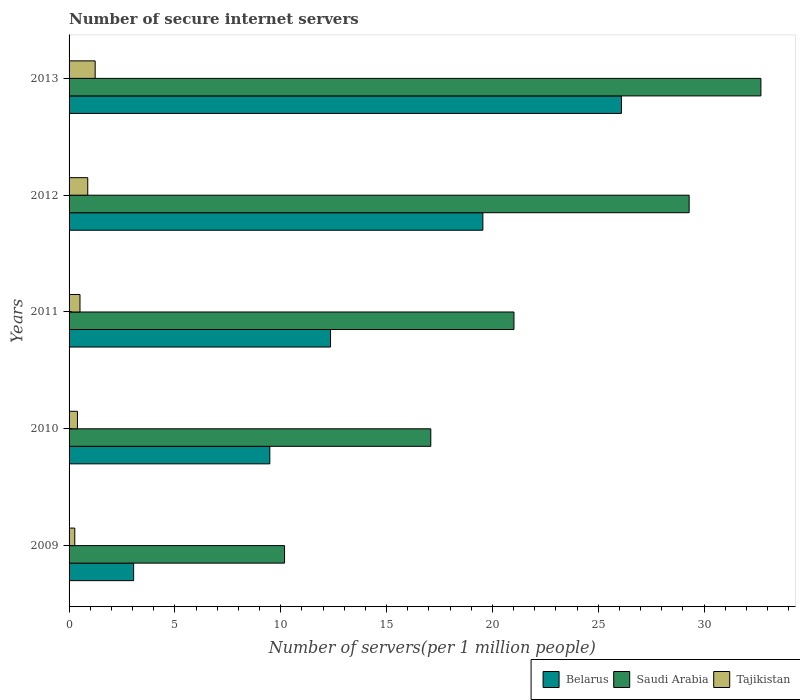How many groups of bars are there?
Ensure brevity in your answer.  5. How many bars are there on the 1st tick from the bottom?
Ensure brevity in your answer.  3. What is the number of secure internet servers in Belarus in 2012?
Offer a very short reply. 19.55. Across all years, what is the maximum number of secure internet servers in Belarus?
Provide a short and direct response. 26.09. Across all years, what is the minimum number of secure internet servers in Tajikistan?
Give a very brief answer. 0.27. In which year was the number of secure internet servers in Belarus maximum?
Provide a succinct answer. 2013. What is the total number of secure internet servers in Tajikistan in the graph?
Provide a short and direct response. 3.3. What is the difference between the number of secure internet servers in Belarus in 2009 and that in 2010?
Your response must be concise. -6.43. What is the difference between the number of secure internet servers in Saudi Arabia in 2009 and the number of secure internet servers in Tajikistan in 2013?
Provide a short and direct response. 8.95. What is the average number of secure internet servers in Belarus per year?
Give a very brief answer. 14.11. In the year 2012, what is the difference between the number of secure internet servers in Tajikistan and number of secure internet servers in Belarus?
Ensure brevity in your answer.  -18.67. In how many years, is the number of secure internet servers in Tajikistan greater than 21 ?
Your answer should be compact. 0. What is the ratio of the number of secure internet servers in Belarus in 2009 to that in 2010?
Keep it short and to the point. 0.32. Is the number of secure internet servers in Tajikistan in 2011 less than that in 2013?
Make the answer very short. Yes. What is the difference between the highest and the second highest number of secure internet servers in Saudi Arabia?
Ensure brevity in your answer.  3.39. What is the difference between the highest and the lowest number of secure internet servers in Saudi Arabia?
Your answer should be compact. 22.5. What does the 3rd bar from the top in 2013 represents?
Give a very brief answer. Belarus. What does the 1st bar from the bottom in 2010 represents?
Ensure brevity in your answer.  Belarus. Is it the case that in every year, the sum of the number of secure internet servers in Saudi Arabia and number of secure internet servers in Belarus is greater than the number of secure internet servers in Tajikistan?
Your answer should be compact. Yes. How many bars are there?
Your answer should be compact. 15. How many years are there in the graph?
Give a very brief answer. 5. Does the graph contain grids?
Your answer should be compact. No. How are the legend labels stacked?
Provide a succinct answer. Horizontal. What is the title of the graph?
Your response must be concise. Number of secure internet servers. Does "Seychelles" appear as one of the legend labels in the graph?
Give a very brief answer. No. What is the label or title of the X-axis?
Offer a very short reply. Number of servers(per 1 million people). What is the Number of servers(per 1 million people) in Belarus in 2009?
Provide a succinct answer. 3.05. What is the Number of servers(per 1 million people) in Saudi Arabia in 2009?
Provide a short and direct response. 10.18. What is the Number of servers(per 1 million people) of Tajikistan in 2009?
Provide a short and direct response. 0.27. What is the Number of servers(per 1 million people) in Belarus in 2010?
Give a very brief answer. 9.48. What is the Number of servers(per 1 million people) in Saudi Arabia in 2010?
Offer a very short reply. 17.09. What is the Number of servers(per 1 million people) of Tajikistan in 2010?
Your response must be concise. 0.4. What is the Number of servers(per 1 million people) of Belarus in 2011?
Offer a very short reply. 12.35. What is the Number of servers(per 1 million people) of Saudi Arabia in 2011?
Make the answer very short. 21.02. What is the Number of servers(per 1 million people) in Tajikistan in 2011?
Offer a very short reply. 0.52. What is the Number of servers(per 1 million people) of Belarus in 2012?
Offer a very short reply. 19.55. What is the Number of servers(per 1 million people) in Saudi Arabia in 2012?
Your answer should be very brief. 29.29. What is the Number of servers(per 1 million people) in Tajikistan in 2012?
Your answer should be compact. 0.88. What is the Number of servers(per 1 million people) in Belarus in 2013?
Your response must be concise. 26.09. What is the Number of servers(per 1 million people) of Saudi Arabia in 2013?
Ensure brevity in your answer.  32.68. What is the Number of servers(per 1 million people) in Tajikistan in 2013?
Your answer should be very brief. 1.23. Across all years, what is the maximum Number of servers(per 1 million people) in Belarus?
Your answer should be compact. 26.09. Across all years, what is the maximum Number of servers(per 1 million people) in Saudi Arabia?
Provide a short and direct response. 32.68. Across all years, what is the maximum Number of servers(per 1 million people) in Tajikistan?
Ensure brevity in your answer.  1.23. Across all years, what is the minimum Number of servers(per 1 million people) of Belarus?
Ensure brevity in your answer.  3.05. Across all years, what is the minimum Number of servers(per 1 million people) of Saudi Arabia?
Provide a short and direct response. 10.18. Across all years, what is the minimum Number of servers(per 1 million people) of Tajikistan?
Offer a very short reply. 0.27. What is the total Number of servers(per 1 million people) in Belarus in the graph?
Your answer should be very brief. 70.53. What is the total Number of servers(per 1 million people) in Saudi Arabia in the graph?
Keep it short and to the point. 110.25. What is the total Number of servers(per 1 million people) of Tajikistan in the graph?
Your response must be concise. 3.3. What is the difference between the Number of servers(per 1 million people) of Belarus in 2009 and that in 2010?
Offer a very short reply. -6.43. What is the difference between the Number of servers(per 1 million people) of Saudi Arabia in 2009 and that in 2010?
Your answer should be compact. -6.91. What is the difference between the Number of servers(per 1 million people) of Tajikistan in 2009 and that in 2010?
Make the answer very short. -0.13. What is the difference between the Number of servers(per 1 million people) of Belarus in 2009 and that in 2011?
Your answer should be compact. -9.3. What is the difference between the Number of servers(per 1 million people) in Saudi Arabia in 2009 and that in 2011?
Your response must be concise. -10.84. What is the difference between the Number of servers(per 1 million people) in Tajikistan in 2009 and that in 2011?
Give a very brief answer. -0.25. What is the difference between the Number of servers(per 1 million people) of Belarus in 2009 and that in 2012?
Your response must be concise. -16.5. What is the difference between the Number of servers(per 1 million people) of Saudi Arabia in 2009 and that in 2012?
Ensure brevity in your answer.  -19.11. What is the difference between the Number of servers(per 1 million people) in Tajikistan in 2009 and that in 2012?
Offer a terse response. -0.61. What is the difference between the Number of servers(per 1 million people) of Belarus in 2009 and that in 2013?
Make the answer very short. -23.04. What is the difference between the Number of servers(per 1 million people) in Saudi Arabia in 2009 and that in 2013?
Keep it short and to the point. -22.5. What is the difference between the Number of servers(per 1 million people) in Tajikistan in 2009 and that in 2013?
Ensure brevity in your answer.  -0.96. What is the difference between the Number of servers(per 1 million people) of Belarus in 2010 and that in 2011?
Offer a terse response. -2.87. What is the difference between the Number of servers(per 1 million people) of Saudi Arabia in 2010 and that in 2011?
Your response must be concise. -3.93. What is the difference between the Number of servers(per 1 million people) of Tajikistan in 2010 and that in 2011?
Your response must be concise. -0.12. What is the difference between the Number of servers(per 1 million people) of Belarus in 2010 and that in 2012?
Give a very brief answer. -10.06. What is the difference between the Number of servers(per 1 million people) in Saudi Arabia in 2010 and that in 2012?
Ensure brevity in your answer.  -12.2. What is the difference between the Number of servers(per 1 million people) of Tajikistan in 2010 and that in 2012?
Offer a terse response. -0.49. What is the difference between the Number of servers(per 1 million people) of Belarus in 2010 and that in 2013?
Your answer should be compact. -16.61. What is the difference between the Number of servers(per 1 million people) of Saudi Arabia in 2010 and that in 2013?
Provide a short and direct response. -15.59. What is the difference between the Number of servers(per 1 million people) of Tajikistan in 2010 and that in 2013?
Provide a succinct answer. -0.84. What is the difference between the Number of servers(per 1 million people) in Belarus in 2011 and that in 2012?
Your answer should be very brief. -7.2. What is the difference between the Number of servers(per 1 million people) in Saudi Arabia in 2011 and that in 2012?
Keep it short and to the point. -8.28. What is the difference between the Number of servers(per 1 million people) of Tajikistan in 2011 and that in 2012?
Your answer should be compact. -0.37. What is the difference between the Number of servers(per 1 million people) of Belarus in 2011 and that in 2013?
Make the answer very short. -13.74. What is the difference between the Number of servers(per 1 million people) in Saudi Arabia in 2011 and that in 2013?
Offer a terse response. -11.67. What is the difference between the Number of servers(per 1 million people) in Tajikistan in 2011 and that in 2013?
Your answer should be very brief. -0.72. What is the difference between the Number of servers(per 1 million people) of Belarus in 2012 and that in 2013?
Ensure brevity in your answer.  -6.55. What is the difference between the Number of servers(per 1 million people) of Saudi Arabia in 2012 and that in 2013?
Provide a succinct answer. -3.39. What is the difference between the Number of servers(per 1 million people) of Tajikistan in 2012 and that in 2013?
Your answer should be very brief. -0.35. What is the difference between the Number of servers(per 1 million people) of Belarus in 2009 and the Number of servers(per 1 million people) of Saudi Arabia in 2010?
Your response must be concise. -14.04. What is the difference between the Number of servers(per 1 million people) of Belarus in 2009 and the Number of servers(per 1 million people) of Tajikistan in 2010?
Your answer should be compact. 2.65. What is the difference between the Number of servers(per 1 million people) in Saudi Arabia in 2009 and the Number of servers(per 1 million people) in Tajikistan in 2010?
Your answer should be very brief. 9.78. What is the difference between the Number of servers(per 1 million people) of Belarus in 2009 and the Number of servers(per 1 million people) of Saudi Arabia in 2011?
Make the answer very short. -17.96. What is the difference between the Number of servers(per 1 million people) in Belarus in 2009 and the Number of servers(per 1 million people) in Tajikistan in 2011?
Give a very brief answer. 2.53. What is the difference between the Number of servers(per 1 million people) in Saudi Arabia in 2009 and the Number of servers(per 1 million people) in Tajikistan in 2011?
Your response must be concise. 9.66. What is the difference between the Number of servers(per 1 million people) of Belarus in 2009 and the Number of servers(per 1 million people) of Saudi Arabia in 2012?
Offer a terse response. -26.24. What is the difference between the Number of servers(per 1 million people) of Belarus in 2009 and the Number of servers(per 1 million people) of Tajikistan in 2012?
Ensure brevity in your answer.  2.17. What is the difference between the Number of servers(per 1 million people) of Saudi Arabia in 2009 and the Number of servers(per 1 million people) of Tajikistan in 2012?
Keep it short and to the point. 9.3. What is the difference between the Number of servers(per 1 million people) in Belarus in 2009 and the Number of servers(per 1 million people) in Saudi Arabia in 2013?
Give a very brief answer. -29.63. What is the difference between the Number of servers(per 1 million people) of Belarus in 2009 and the Number of servers(per 1 million people) of Tajikistan in 2013?
Give a very brief answer. 1.82. What is the difference between the Number of servers(per 1 million people) in Saudi Arabia in 2009 and the Number of servers(per 1 million people) in Tajikistan in 2013?
Offer a terse response. 8.95. What is the difference between the Number of servers(per 1 million people) of Belarus in 2010 and the Number of servers(per 1 million people) of Saudi Arabia in 2011?
Your response must be concise. -11.53. What is the difference between the Number of servers(per 1 million people) of Belarus in 2010 and the Number of servers(per 1 million people) of Tajikistan in 2011?
Offer a terse response. 8.97. What is the difference between the Number of servers(per 1 million people) in Saudi Arabia in 2010 and the Number of servers(per 1 million people) in Tajikistan in 2011?
Your answer should be compact. 16.57. What is the difference between the Number of servers(per 1 million people) of Belarus in 2010 and the Number of servers(per 1 million people) of Saudi Arabia in 2012?
Make the answer very short. -19.81. What is the difference between the Number of servers(per 1 million people) in Belarus in 2010 and the Number of servers(per 1 million people) in Tajikistan in 2012?
Make the answer very short. 8.6. What is the difference between the Number of servers(per 1 million people) of Saudi Arabia in 2010 and the Number of servers(per 1 million people) of Tajikistan in 2012?
Ensure brevity in your answer.  16.2. What is the difference between the Number of servers(per 1 million people) of Belarus in 2010 and the Number of servers(per 1 million people) of Saudi Arabia in 2013?
Ensure brevity in your answer.  -23.2. What is the difference between the Number of servers(per 1 million people) of Belarus in 2010 and the Number of servers(per 1 million people) of Tajikistan in 2013?
Ensure brevity in your answer.  8.25. What is the difference between the Number of servers(per 1 million people) in Saudi Arabia in 2010 and the Number of servers(per 1 million people) in Tajikistan in 2013?
Your response must be concise. 15.85. What is the difference between the Number of servers(per 1 million people) of Belarus in 2011 and the Number of servers(per 1 million people) of Saudi Arabia in 2012?
Keep it short and to the point. -16.94. What is the difference between the Number of servers(per 1 million people) in Belarus in 2011 and the Number of servers(per 1 million people) in Tajikistan in 2012?
Ensure brevity in your answer.  11.47. What is the difference between the Number of servers(per 1 million people) of Saudi Arabia in 2011 and the Number of servers(per 1 million people) of Tajikistan in 2012?
Keep it short and to the point. 20.13. What is the difference between the Number of servers(per 1 million people) in Belarus in 2011 and the Number of servers(per 1 million people) in Saudi Arabia in 2013?
Your answer should be compact. -20.33. What is the difference between the Number of servers(per 1 million people) in Belarus in 2011 and the Number of servers(per 1 million people) in Tajikistan in 2013?
Ensure brevity in your answer.  11.12. What is the difference between the Number of servers(per 1 million people) of Saudi Arabia in 2011 and the Number of servers(per 1 million people) of Tajikistan in 2013?
Give a very brief answer. 19.78. What is the difference between the Number of servers(per 1 million people) of Belarus in 2012 and the Number of servers(per 1 million people) of Saudi Arabia in 2013?
Make the answer very short. -13.13. What is the difference between the Number of servers(per 1 million people) of Belarus in 2012 and the Number of servers(per 1 million people) of Tajikistan in 2013?
Your response must be concise. 18.32. What is the difference between the Number of servers(per 1 million people) of Saudi Arabia in 2012 and the Number of servers(per 1 million people) of Tajikistan in 2013?
Give a very brief answer. 28.06. What is the average Number of servers(per 1 million people) in Belarus per year?
Give a very brief answer. 14.11. What is the average Number of servers(per 1 million people) of Saudi Arabia per year?
Your answer should be very brief. 22.05. What is the average Number of servers(per 1 million people) of Tajikistan per year?
Give a very brief answer. 0.66. In the year 2009, what is the difference between the Number of servers(per 1 million people) in Belarus and Number of servers(per 1 million people) in Saudi Arabia?
Your response must be concise. -7.13. In the year 2009, what is the difference between the Number of servers(per 1 million people) of Belarus and Number of servers(per 1 million people) of Tajikistan?
Provide a short and direct response. 2.78. In the year 2009, what is the difference between the Number of servers(per 1 million people) in Saudi Arabia and Number of servers(per 1 million people) in Tajikistan?
Ensure brevity in your answer.  9.91. In the year 2010, what is the difference between the Number of servers(per 1 million people) in Belarus and Number of servers(per 1 million people) in Saudi Arabia?
Give a very brief answer. -7.6. In the year 2010, what is the difference between the Number of servers(per 1 million people) in Belarus and Number of servers(per 1 million people) in Tajikistan?
Keep it short and to the point. 9.09. In the year 2010, what is the difference between the Number of servers(per 1 million people) of Saudi Arabia and Number of servers(per 1 million people) of Tajikistan?
Keep it short and to the point. 16.69. In the year 2011, what is the difference between the Number of servers(per 1 million people) in Belarus and Number of servers(per 1 million people) in Saudi Arabia?
Give a very brief answer. -8.66. In the year 2011, what is the difference between the Number of servers(per 1 million people) in Belarus and Number of servers(per 1 million people) in Tajikistan?
Offer a terse response. 11.84. In the year 2011, what is the difference between the Number of servers(per 1 million people) of Saudi Arabia and Number of servers(per 1 million people) of Tajikistan?
Make the answer very short. 20.5. In the year 2012, what is the difference between the Number of servers(per 1 million people) of Belarus and Number of servers(per 1 million people) of Saudi Arabia?
Provide a succinct answer. -9.74. In the year 2012, what is the difference between the Number of servers(per 1 million people) in Belarus and Number of servers(per 1 million people) in Tajikistan?
Your answer should be compact. 18.67. In the year 2012, what is the difference between the Number of servers(per 1 million people) in Saudi Arabia and Number of servers(per 1 million people) in Tajikistan?
Offer a terse response. 28.41. In the year 2013, what is the difference between the Number of servers(per 1 million people) in Belarus and Number of servers(per 1 million people) in Saudi Arabia?
Give a very brief answer. -6.59. In the year 2013, what is the difference between the Number of servers(per 1 million people) of Belarus and Number of servers(per 1 million people) of Tajikistan?
Keep it short and to the point. 24.86. In the year 2013, what is the difference between the Number of servers(per 1 million people) of Saudi Arabia and Number of servers(per 1 million people) of Tajikistan?
Provide a short and direct response. 31.45. What is the ratio of the Number of servers(per 1 million people) in Belarus in 2009 to that in 2010?
Your answer should be very brief. 0.32. What is the ratio of the Number of servers(per 1 million people) of Saudi Arabia in 2009 to that in 2010?
Ensure brevity in your answer.  0.6. What is the ratio of the Number of servers(per 1 million people) of Tajikistan in 2009 to that in 2010?
Your answer should be very brief. 0.68. What is the ratio of the Number of servers(per 1 million people) in Belarus in 2009 to that in 2011?
Give a very brief answer. 0.25. What is the ratio of the Number of servers(per 1 million people) of Saudi Arabia in 2009 to that in 2011?
Offer a very short reply. 0.48. What is the ratio of the Number of servers(per 1 million people) in Tajikistan in 2009 to that in 2011?
Your response must be concise. 0.52. What is the ratio of the Number of servers(per 1 million people) of Belarus in 2009 to that in 2012?
Make the answer very short. 0.16. What is the ratio of the Number of servers(per 1 million people) in Saudi Arabia in 2009 to that in 2012?
Keep it short and to the point. 0.35. What is the ratio of the Number of servers(per 1 million people) in Tajikistan in 2009 to that in 2012?
Keep it short and to the point. 0.31. What is the ratio of the Number of servers(per 1 million people) of Belarus in 2009 to that in 2013?
Make the answer very short. 0.12. What is the ratio of the Number of servers(per 1 million people) in Saudi Arabia in 2009 to that in 2013?
Make the answer very short. 0.31. What is the ratio of the Number of servers(per 1 million people) in Tajikistan in 2009 to that in 2013?
Ensure brevity in your answer.  0.22. What is the ratio of the Number of servers(per 1 million people) in Belarus in 2010 to that in 2011?
Keep it short and to the point. 0.77. What is the ratio of the Number of servers(per 1 million people) in Saudi Arabia in 2010 to that in 2011?
Keep it short and to the point. 0.81. What is the ratio of the Number of servers(per 1 million people) in Tajikistan in 2010 to that in 2011?
Offer a very short reply. 0.77. What is the ratio of the Number of servers(per 1 million people) of Belarus in 2010 to that in 2012?
Your answer should be compact. 0.49. What is the ratio of the Number of servers(per 1 million people) in Saudi Arabia in 2010 to that in 2012?
Ensure brevity in your answer.  0.58. What is the ratio of the Number of servers(per 1 million people) in Tajikistan in 2010 to that in 2012?
Ensure brevity in your answer.  0.45. What is the ratio of the Number of servers(per 1 million people) in Belarus in 2010 to that in 2013?
Keep it short and to the point. 0.36. What is the ratio of the Number of servers(per 1 million people) in Saudi Arabia in 2010 to that in 2013?
Offer a very short reply. 0.52. What is the ratio of the Number of servers(per 1 million people) in Tajikistan in 2010 to that in 2013?
Offer a terse response. 0.32. What is the ratio of the Number of servers(per 1 million people) in Belarus in 2011 to that in 2012?
Give a very brief answer. 0.63. What is the ratio of the Number of servers(per 1 million people) of Saudi Arabia in 2011 to that in 2012?
Keep it short and to the point. 0.72. What is the ratio of the Number of servers(per 1 million people) in Tajikistan in 2011 to that in 2012?
Your answer should be compact. 0.58. What is the ratio of the Number of servers(per 1 million people) in Belarus in 2011 to that in 2013?
Offer a very short reply. 0.47. What is the ratio of the Number of servers(per 1 million people) in Saudi Arabia in 2011 to that in 2013?
Ensure brevity in your answer.  0.64. What is the ratio of the Number of servers(per 1 million people) in Tajikistan in 2011 to that in 2013?
Your answer should be compact. 0.42. What is the ratio of the Number of servers(per 1 million people) of Belarus in 2012 to that in 2013?
Give a very brief answer. 0.75. What is the ratio of the Number of servers(per 1 million people) of Saudi Arabia in 2012 to that in 2013?
Make the answer very short. 0.9. What is the ratio of the Number of servers(per 1 million people) in Tajikistan in 2012 to that in 2013?
Your response must be concise. 0.72. What is the difference between the highest and the second highest Number of servers(per 1 million people) in Belarus?
Your response must be concise. 6.55. What is the difference between the highest and the second highest Number of servers(per 1 million people) in Saudi Arabia?
Your answer should be very brief. 3.39. What is the difference between the highest and the second highest Number of servers(per 1 million people) in Tajikistan?
Provide a short and direct response. 0.35. What is the difference between the highest and the lowest Number of servers(per 1 million people) of Belarus?
Give a very brief answer. 23.04. What is the difference between the highest and the lowest Number of servers(per 1 million people) in Saudi Arabia?
Keep it short and to the point. 22.5. 